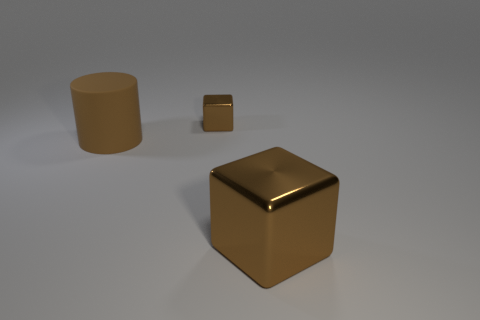Is there any other thing that has the same material as the big brown cylinder?
Your answer should be compact. No. What shape is the brown thing that is to the right of the tiny brown cube?
Your answer should be compact. Cube. Does the block that is to the right of the small brown cube have the same color as the tiny thing?
Your answer should be compact. Yes. What material is the other block that is the same color as the small block?
Your answer should be very brief. Metal. There is a cube behind the brown matte cylinder; is its size the same as the brown rubber cylinder?
Make the answer very short. No. Are there any other big cylinders that have the same color as the large matte cylinder?
Provide a short and direct response. No. Is there a large cylinder on the left side of the big thing that is to the right of the large brown cylinder?
Your answer should be very brief. Yes. Are there any brown things that have the same material as the tiny block?
Ensure brevity in your answer.  Yes. What is the material of the block behind the large object that is to the left of the big brown shiny object?
Your response must be concise. Metal. There is a thing that is both on the left side of the big block and right of the big brown rubber object; what material is it made of?
Offer a very short reply. Metal. 